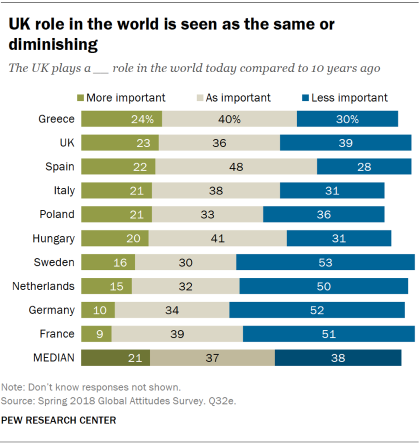Point out several critical features in this image. The average of all the "as important" bars, excluding the median, is 0.371... According to the given data, France has the lowest value for 'More Important.' 